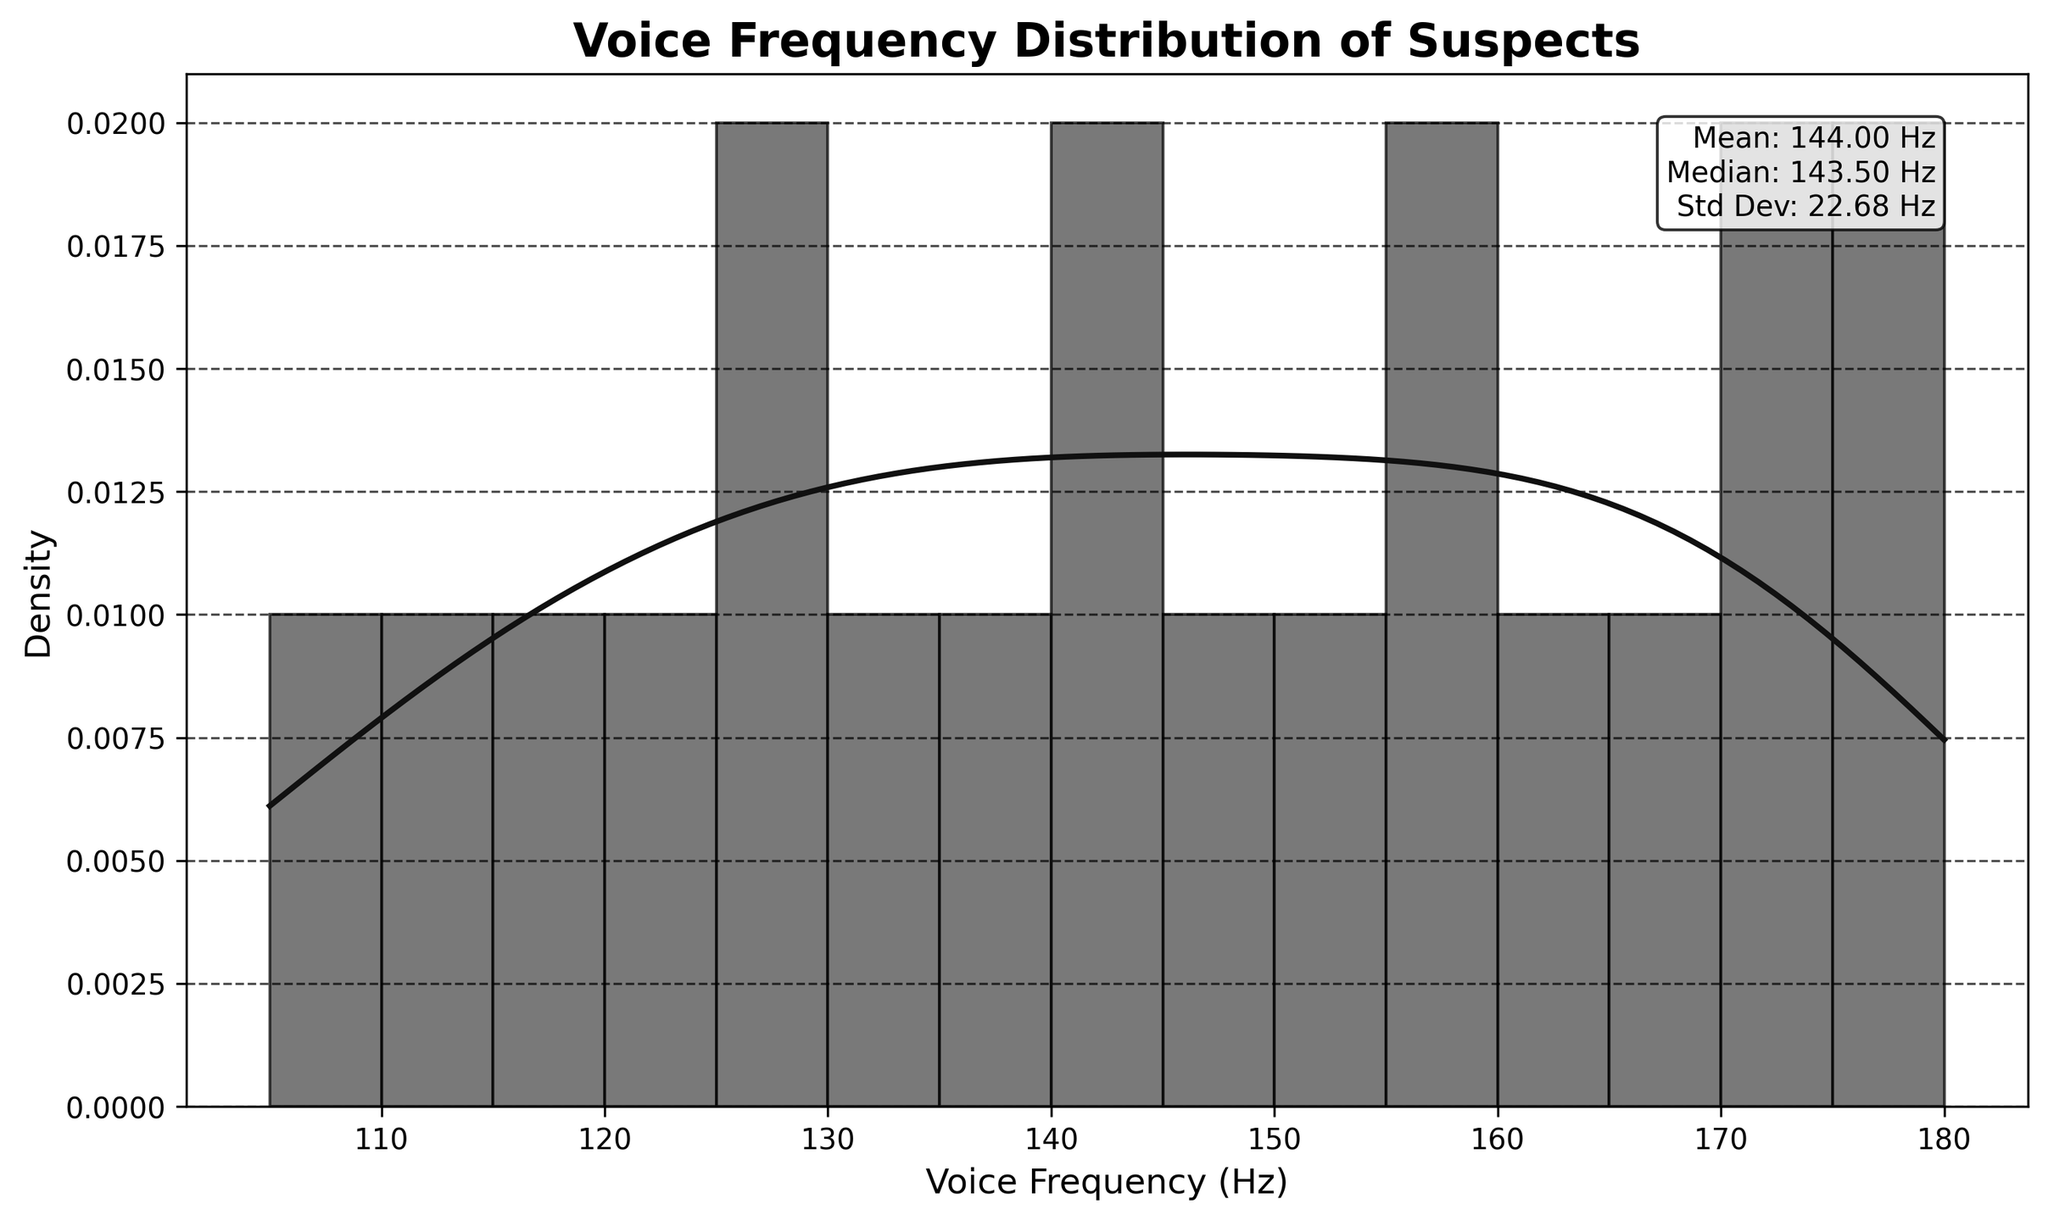What is the title of the plot? The title of the plot appears at the top and provides a summary of what the figure represents.
Answer: Voice Frequency Distribution of Suspects What does the x-axis represent in the plot? The x-axis represents the variable being measured, which is labeled accordingly in the figure.
Answer: Voice Frequency (Hz) What is the mean voice frequency of the suspects? The mean is the average of all the values shown. In the plot, it is provided in the text box.
Answer: 142.5 Hz How many voice frequency bins are shown in the histogram? By counting the number of distinct bins in the histogram, you can determine the total number of bins.
Answer: 15 What is the range of voice frequencies in the histogram? The range can be found by looking at the minimum and maximum values on the x-axis.
Answer: 105 Hz to 180 Hz Which voice frequency value has the highest density according to the KDE curve? The peak of the KDE curve indicates the voice frequency value with the highest density.
Answer: Around 142 Hz How does the frequency distribution change as voice frequency increases? By observing the shape of the histogram and KDE curve, you can describe the trend in the distribution as frequencies increase.
Answer: The frequency increases and then decreases, forming a roughly bell-shaped curve Is there more than one peak in the KDE curve? A multimodal distribution would show multiple peaks in the KDE curve.
Answer: No, there is one peak What is the standard deviation of the voice frequencies? The standard deviation is provided in the text box on the plot, summarizing the dispersion of the data around the mean.
Answer: 23.29 Hz Which voice frequency bin has the least density? By identifying the bin with the lowest bar height or density value, you can determine which has the least density.
Answer: Around 110-115 Hz 